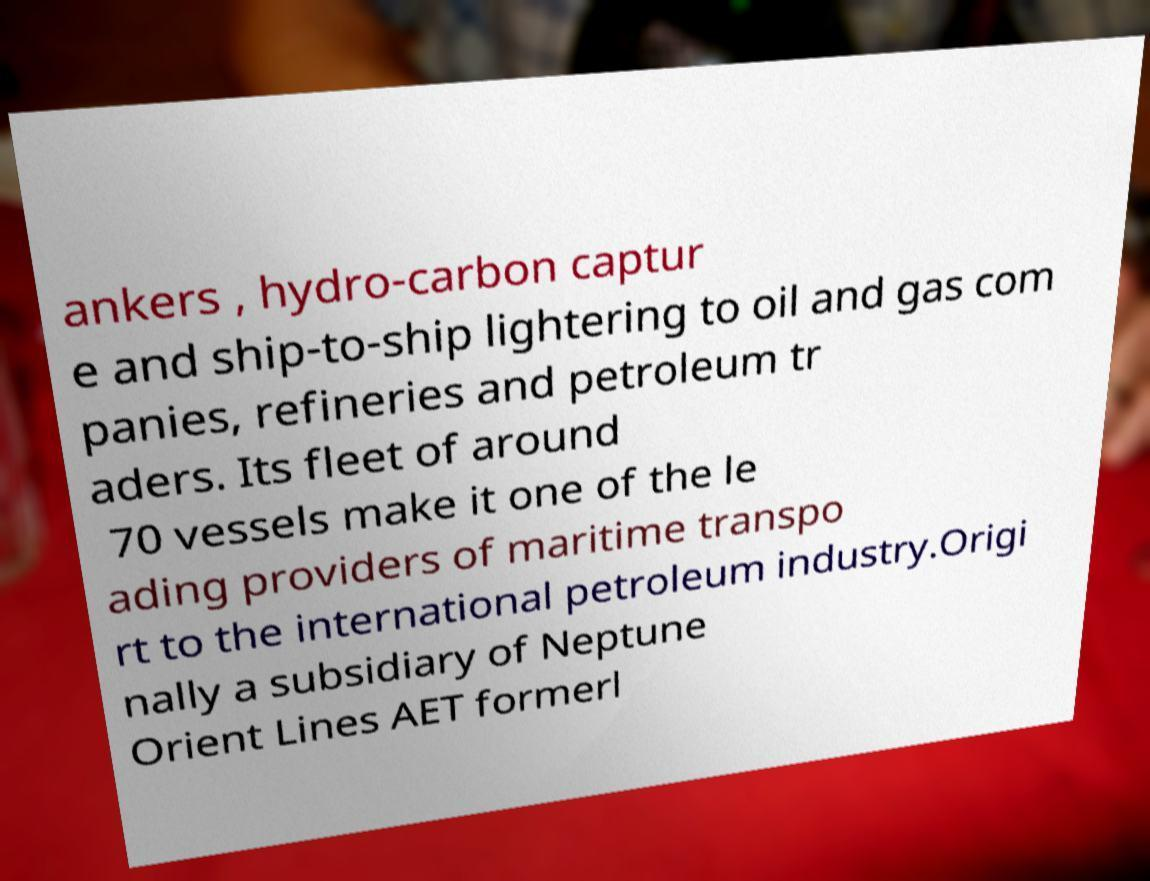Could you assist in decoding the text presented in this image and type it out clearly? ankers , hydro-carbon captur e and ship-to-ship lightering to oil and gas com panies, refineries and petroleum tr aders. Its fleet of around 70 vessels make it one of the le ading providers of maritime transpo rt to the international petroleum industry.Origi nally a subsidiary of Neptune Orient Lines AET formerl 